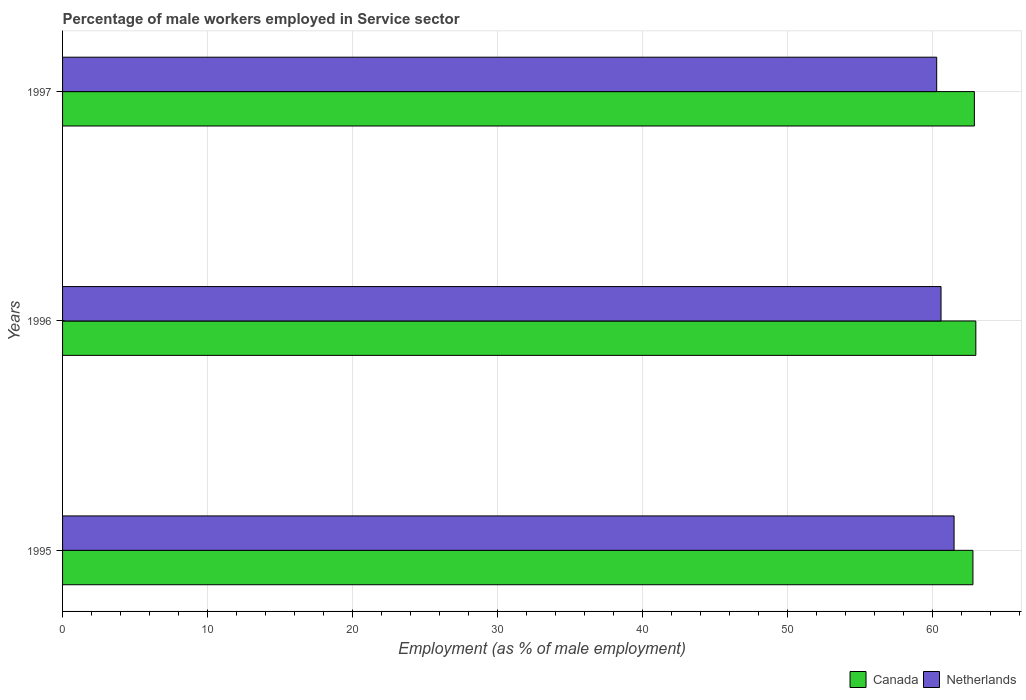How many different coloured bars are there?
Provide a short and direct response. 2. How many groups of bars are there?
Keep it short and to the point. 3. Are the number of bars per tick equal to the number of legend labels?
Keep it short and to the point. Yes. How many bars are there on the 1st tick from the top?
Provide a short and direct response. 2. How many bars are there on the 3rd tick from the bottom?
Make the answer very short. 2. In how many cases, is the number of bars for a given year not equal to the number of legend labels?
Your answer should be compact. 0. What is the percentage of male workers employed in Service sector in Canada in 1997?
Ensure brevity in your answer.  62.9. Across all years, what is the minimum percentage of male workers employed in Service sector in Canada?
Your answer should be very brief. 62.8. In which year was the percentage of male workers employed in Service sector in Canada minimum?
Offer a terse response. 1995. What is the total percentage of male workers employed in Service sector in Netherlands in the graph?
Give a very brief answer. 182.4. What is the difference between the percentage of male workers employed in Service sector in Netherlands in 1995 and that in 1996?
Ensure brevity in your answer.  0.9. What is the difference between the percentage of male workers employed in Service sector in Netherlands in 1996 and the percentage of male workers employed in Service sector in Canada in 1995?
Keep it short and to the point. -2.2. What is the average percentage of male workers employed in Service sector in Canada per year?
Provide a succinct answer. 62.9. In the year 1997, what is the difference between the percentage of male workers employed in Service sector in Netherlands and percentage of male workers employed in Service sector in Canada?
Offer a very short reply. -2.6. In how many years, is the percentage of male workers employed in Service sector in Netherlands greater than 22 %?
Provide a succinct answer. 3. What is the ratio of the percentage of male workers employed in Service sector in Netherlands in 1996 to that in 1997?
Give a very brief answer. 1. Is the difference between the percentage of male workers employed in Service sector in Netherlands in 1996 and 1997 greater than the difference between the percentage of male workers employed in Service sector in Canada in 1996 and 1997?
Your response must be concise. Yes. What is the difference between the highest and the second highest percentage of male workers employed in Service sector in Netherlands?
Make the answer very short. 0.9. What is the difference between the highest and the lowest percentage of male workers employed in Service sector in Netherlands?
Offer a terse response. 1.2. In how many years, is the percentage of male workers employed in Service sector in Netherlands greater than the average percentage of male workers employed in Service sector in Netherlands taken over all years?
Offer a very short reply. 1. What does the 2nd bar from the top in 1996 represents?
Keep it short and to the point. Canada. How many bars are there?
Ensure brevity in your answer.  6. How many years are there in the graph?
Your answer should be compact. 3. Does the graph contain any zero values?
Make the answer very short. No. Does the graph contain grids?
Keep it short and to the point. Yes. How many legend labels are there?
Keep it short and to the point. 2. How are the legend labels stacked?
Ensure brevity in your answer.  Horizontal. What is the title of the graph?
Provide a short and direct response. Percentage of male workers employed in Service sector. Does "Lesotho" appear as one of the legend labels in the graph?
Offer a very short reply. No. What is the label or title of the X-axis?
Make the answer very short. Employment (as % of male employment). What is the Employment (as % of male employment) of Canada in 1995?
Make the answer very short. 62.8. What is the Employment (as % of male employment) in Netherlands in 1995?
Offer a terse response. 61.5. What is the Employment (as % of male employment) of Canada in 1996?
Keep it short and to the point. 63. What is the Employment (as % of male employment) of Netherlands in 1996?
Your answer should be compact. 60.6. What is the Employment (as % of male employment) of Canada in 1997?
Ensure brevity in your answer.  62.9. What is the Employment (as % of male employment) in Netherlands in 1997?
Keep it short and to the point. 60.3. Across all years, what is the maximum Employment (as % of male employment) of Netherlands?
Your response must be concise. 61.5. Across all years, what is the minimum Employment (as % of male employment) in Canada?
Your response must be concise. 62.8. Across all years, what is the minimum Employment (as % of male employment) in Netherlands?
Your answer should be very brief. 60.3. What is the total Employment (as % of male employment) of Canada in the graph?
Your answer should be very brief. 188.7. What is the total Employment (as % of male employment) in Netherlands in the graph?
Provide a succinct answer. 182.4. What is the difference between the Employment (as % of male employment) in Canada in 1995 and that in 1996?
Offer a terse response. -0.2. What is the difference between the Employment (as % of male employment) in Canada in 1995 and that in 1997?
Make the answer very short. -0.1. What is the difference between the Employment (as % of male employment) in Canada in 1996 and that in 1997?
Offer a terse response. 0.1. What is the difference between the Employment (as % of male employment) in Netherlands in 1996 and that in 1997?
Keep it short and to the point. 0.3. What is the difference between the Employment (as % of male employment) of Canada in 1995 and the Employment (as % of male employment) of Netherlands in 1996?
Your response must be concise. 2.2. What is the average Employment (as % of male employment) of Canada per year?
Your answer should be very brief. 62.9. What is the average Employment (as % of male employment) in Netherlands per year?
Offer a very short reply. 60.8. In the year 1995, what is the difference between the Employment (as % of male employment) of Canada and Employment (as % of male employment) of Netherlands?
Your response must be concise. 1.3. What is the ratio of the Employment (as % of male employment) of Netherlands in 1995 to that in 1996?
Give a very brief answer. 1.01. What is the ratio of the Employment (as % of male employment) of Netherlands in 1995 to that in 1997?
Provide a short and direct response. 1.02. What is the ratio of the Employment (as % of male employment) in Canada in 1996 to that in 1997?
Provide a succinct answer. 1. What is the difference between the highest and the second highest Employment (as % of male employment) in Netherlands?
Your answer should be compact. 0.9. What is the difference between the highest and the lowest Employment (as % of male employment) of Canada?
Make the answer very short. 0.2. 